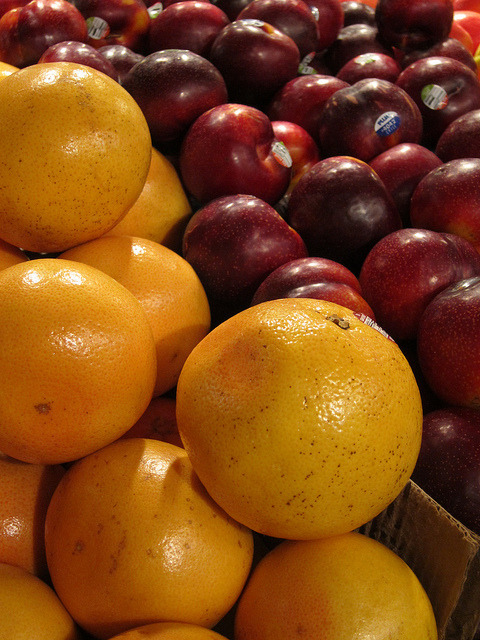Can you tell me the best season to purchase these fruits? Oranges are typically in season during the winter months, while plums are best in late summer when they are at their most sweet and juicy. What are some of the health benefits of these fruits? Oranges are excellent for boosting the immune system due to their high vitamin C content, whereas plums contain antioxidants that can help reduce the risk of several chronic diseases, along with fiber that aids in digestion. 